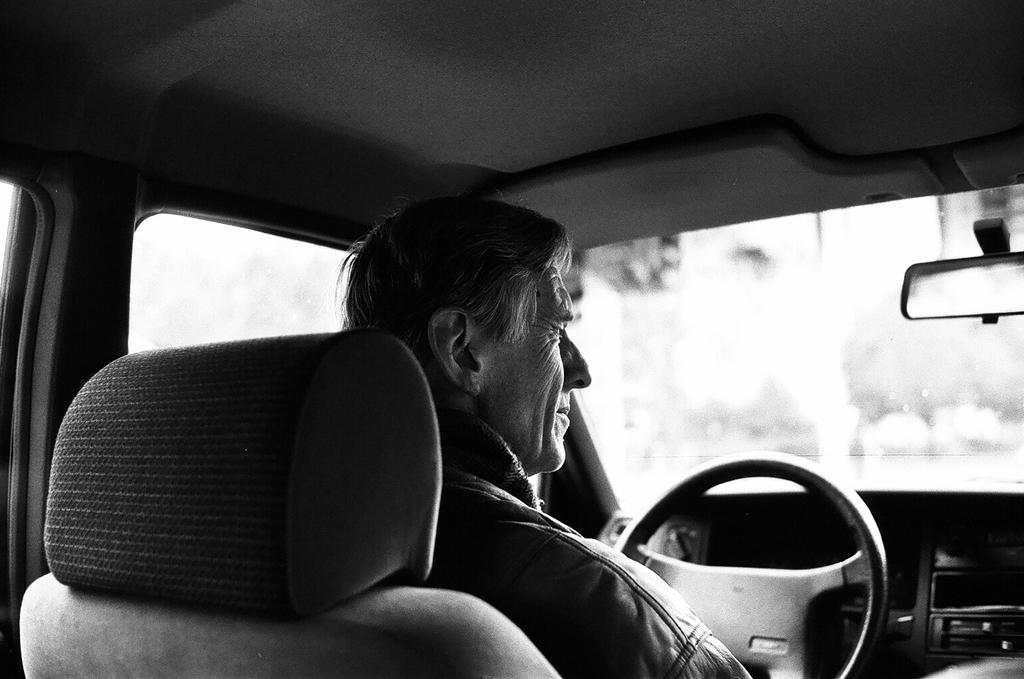What is the man doing in the image? The man is sitting on a car. What feature of the car is visible in the image? The car has a steering wheel. What type of donkey can be seen pulling the car in the image? There is no donkey present in the image; the man is sitting on the car. How does the man control the car in the image? The man does not control the car in the image, as there is no indication of him driving or operating it. 